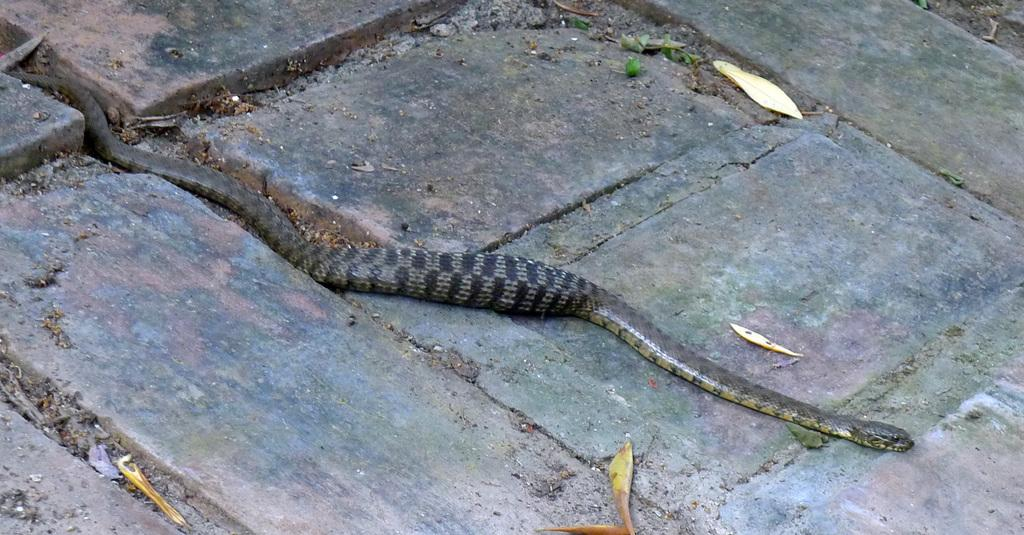What type of animal is present in the image? There is a snake in the image. Can you describe the color of the snake? The snake is black and gray in color. What else can be seen in the image besides the snake? There are dry leaves and a footpath in the image. What is the rate of the ocean waves in the image? There is no ocean or waves present in the image; it features a snake, dry leaves, and a footpath. 